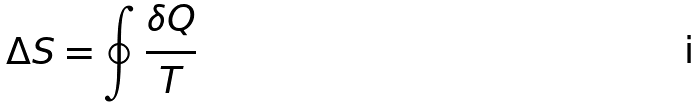<formula> <loc_0><loc_0><loc_500><loc_500>\Delta S = \oint \frac { \delta Q } { T }</formula> 